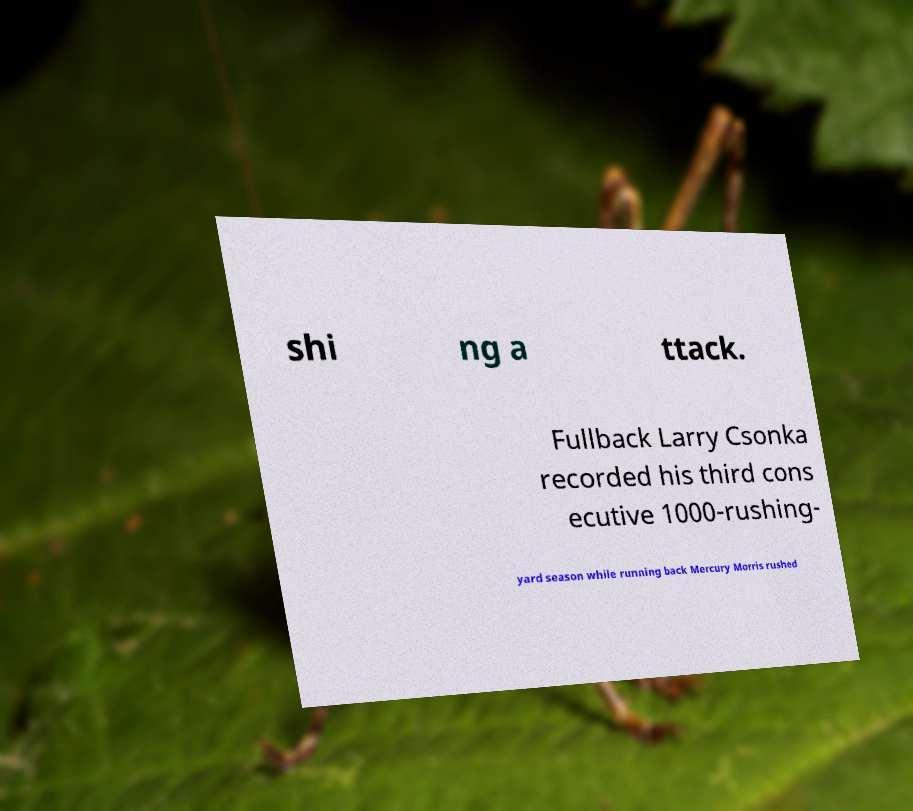Can you accurately transcribe the text from the provided image for me? shi ng a ttack. Fullback Larry Csonka recorded his third cons ecutive 1000-rushing- yard season while running back Mercury Morris rushed 